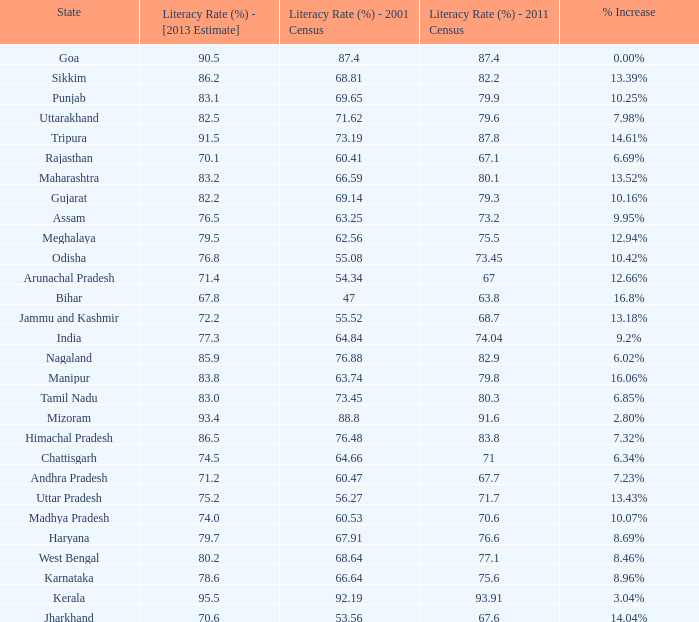What is the average estimated 2013 literacy rate for the states that had a literacy rate of 68.81% in the 2001 census and a literacy rate higher than 79.6% in the 2011 census? 86.2. 